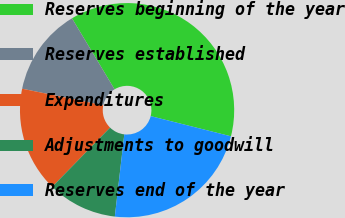Convert chart. <chart><loc_0><loc_0><loc_500><loc_500><pie_chart><fcel>Reserves beginning of the year<fcel>Reserves established<fcel>Expenditures<fcel>Adjustments to goodwill<fcel>Reserves end of the year<nl><fcel>37.52%<fcel>13.19%<fcel>15.9%<fcel>10.49%<fcel>22.9%<nl></chart> 